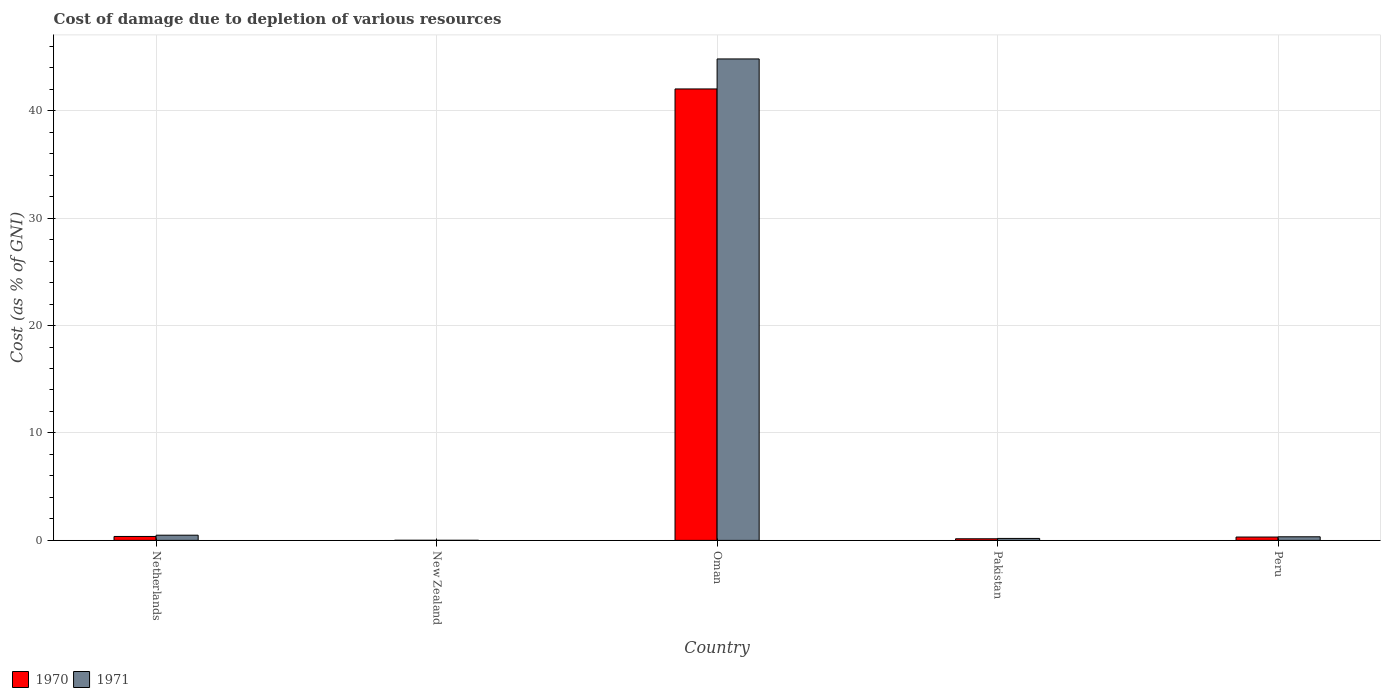How many different coloured bars are there?
Keep it short and to the point. 2. How many groups of bars are there?
Your answer should be very brief. 5. Are the number of bars per tick equal to the number of legend labels?
Make the answer very short. Yes. Are the number of bars on each tick of the X-axis equal?
Provide a succinct answer. Yes. In how many cases, is the number of bars for a given country not equal to the number of legend labels?
Keep it short and to the point. 0. What is the cost of damage caused due to the depletion of various resources in 1971 in Netherlands?
Ensure brevity in your answer.  0.48. Across all countries, what is the maximum cost of damage caused due to the depletion of various resources in 1971?
Offer a very short reply. 44.82. Across all countries, what is the minimum cost of damage caused due to the depletion of various resources in 1970?
Your response must be concise. 0.01. In which country was the cost of damage caused due to the depletion of various resources in 1970 maximum?
Offer a terse response. Oman. In which country was the cost of damage caused due to the depletion of various resources in 1971 minimum?
Give a very brief answer. New Zealand. What is the total cost of damage caused due to the depletion of various resources in 1970 in the graph?
Your answer should be compact. 42.86. What is the difference between the cost of damage caused due to the depletion of various resources in 1971 in Netherlands and that in Pakistan?
Provide a succinct answer. 0.3. What is the difference between the cost of damage caused due to the depletion of various resources in 1970 in Pakistan and the cost of damage caused due to the depletion of various resources in 1971 in New Zealand?
Ensure brevity in your answer.  0.14. What is the average cost of damage caused due to the depletion of various resources in 1970 per country?
Give a very brief answer. 8.57. What is the difference between the cost of damage caused due to the depletion of various resources of/in 1971 and cost of damage caused due to the depletion of various resources of/in 1970 in New Zealand?
Offer a terse response. -0. In how many countries, is the cost of damage caused due to the depletion of various resources in 1970 greater than 42 %?
Offer a terse response. 1. What is the ratio of the cost of damage caused due to the depletion of various resources in 1970 in New Zealand to that in Pakistan?
Give a very brief answer. 0.07. Is the cost of damage caused due to the depletion of various resources in 1971 in Netherlands less than that in New Zealand?
Offer a very short reply. No. What is the difference between the highest and the second highest cost of damage caused due to the depletion of various resources in 1970?
Ensure brevity in your answer.  0.06. What is the difference between the highest and the lowest cost of damage caused due to the depletion of various resources in 1970?
Your answer should be very brief. 42.01. What does the 1st bar from the left in Netherlands represents?
Your answer should be very brief. 1970. What does the 1st bar from the right in Netherlands represents?
Offer a very short reply. 1971. How many bars are there?
Keep it short and to the point. 10. Are all the bars in the graph horizontal?
Make the answer very short. No. What is the difference between two consecutive major ticks on the Y-axis?
Ensure brevity in your answer.  10. Are the values on the major ticks of Y-axis written in scientific E-notation?
Your response must be concise. No. Where does the legend appear in the graph?
Ensure brevity in your answer.  Bottom left. What is the title of the graph?
Offer a very short reply. Cost of damage due to depletion of various resources. What is the label or title of the X-axis?
Provide a short and direct response. Country. What is the label or title of the Y-axis?
Provide a succinct answer. Cost (as % of GNI). What is the Cost (as % of GNI) in 1970 in Netherlands?
Provide a short and direct response. 0.37. What is the Cost (as % of GNI) of 1971 in Netherlands?
Provide a short and direct response. 0.48. What is the Cost (as % of GNI) of 1970 in New Zealand?
Offer a very short reply. 0.01. What is the Cost (as % of GNI) of 1971 in New Zealand?
Your answer should be compact. 0.01. What is the Cost (as % of GNI) of 1970 in Oman?
Provide a short and direct response. 42.02. What is the Cost (as % of GNI) in 1971 in Oman?
Provide a short and direct response. 44.82. What is the Cost (as % of GNI) of 1970 in Pakistan?
Make the answer very short. 0.15. What is the Cost (as % of GNI) of 1971 in Pakistan?
Keep it short and to the point. 0.18. What is the Cost (as % of GNI) in 1970 in Peru?
Provide a succinct answer. 0.31. What is the Cost (as % of GNI) in 1971 in Peru?
Keep it short and to the point. 0.33. Across all countries, what is the maximum Cost (as % of GNI) of 1970?
Provide a succinct answer. 42.02. Across all countries, what is the maximum Cost (as % of GNI) in 1971?
Offer a terse response. 44.82. Across all countries, what is the minimum Cost (as % of GNI) of 1970?
Provide a succinct answer. 0.01. Across all countries, what is the minimum Cost (as % of GNI) in 1971?
Keep it short and to the point. 0.01. What is the total Cost (as % of GNI) of 1970 in the graph?
Give a very brief answer. 42.86. What is the total Cost (as % of GNI) of 1971 in the graph?
Provide a succinct answer. 45.82. What is the difference between the Cost (as % of GNI) in 1970 in Netherlands and that in New Zealand?
Make the answer very short. 0.36. What is the difference between the Cost (as % of GNI) in 1971 in Netherlands and that in New Zealand?
Offer a very short reply. 0.48. What is the difference between the Cost (as % of GNI) in 1970 in Netherlands and that in Oman?
Offer a terse response. -41.66. What is the difference between the Cost (as % of GNI) of 1971 in Netherlands and that in Oman?
Keep it short and to the point. -44.33. What is the difference between the Cost (as % of GNI) in 1970 in Netherlands and that in Pakistan?
Keep it short and to the point. 0.22. What is the difference between the Cost (as % of GNI) of 1971 in Netherlands and that in Pakistan?
Ensure brevity in your answer.  0.3. What is the difference between the Cost (as % of GNI) of 1970 in Netherlands and that in Peru?
Keep it short and to the point. 0.06. What is the difference between the Cost (as % of GNI) of 1971 in Netherlands and that in Peru?
Your response must be concise. 0.15. What is the difference between the Cost (as % of GNI) in 1970 in New Zealand and that in Oman?
Provide a succinct answer. -42.01. What is the difference between the Cost (as % of GNI) of 1971 in New Zealand and that in Oman?
Keep it short and to the point. -44.81. What is the difference between the Cost (as % of GNI) of 1970 in New Zealand and that in Pakistan?
Provide a succinct answer. -0.14. What is the difference between the Cost (as % of GNI) in 1971 in New Zealand and that in Pakistan?
Provide a succinct answer. -0.17. What is the difference between the Cost (as % of GNI) of 1970 in New Zealand and that in Peru?
Offer a very short reply. -0.3. What is the difference between the Cost (as % of GNI) in 1971 in New Zealand and that in Peru?
Offer a very short reply. -0.33. What is the difference between the Cost (as % of GNI) of 1970 in Oman and that in Pakistan?
Provide a short and direct response. 41.87. What is the difference between the Cost (as % of GNI) in 1971 in Oman and that in Pakistan?
Your answer should be compact. 44.63. What is the difference between the Cost (as % of GNI) of 1970 in Oman and that in Peru?
Ensure brevity in your answer.  41.71. What is the difference between the Cost (as % of GNI) of 1971 in Oman and that in Peru?
Make the answer very short. 44.48. What is the difference between the Cost (as % of GNI) of 1970 in Pakistan and that in Peru?
Ensure brevity in your answer.  -0.16. What is the difference between the Cost (as % of GNI) in 1971 in Pakistan and that in Peru?
Your answer should be compact. -0.15. What is the difference between the Cost (as % of GNI) of 1970 in Netherlands and the Cost (as % of GNI) of 1971 in New Zealand?
Ensure brevity in your answer.  0.36. What is the difference between the Cost (as % of GNI) of 1970 in Netherlands and the Cost (as % of GNI) of 1971 in Oman?
Offer a terse response. -44.45. What is the difference between the Cost (as % of GNI) in 1970 in Netherlands and the Cost (as % of GNI) in 1971 in Pakistan?
Give a very brief answer. 0.18. What is the difference between the Cost (as % of GNI) in 1970 in Netherlands and the Cost (as % of GNI) in 1971 in Peru?
Your answer should be very brief. 0.03. What is the difference between the Cost (as % of GNI) of 1970 in New Zealand and the Cost (as % of GNI) of 1971 in Oman?
Give a very brief answer. -44.8. What is the difference between the Cost (as % of GNI) of 1970 in New Zealand and the Cost (as % of GNI) of 1971 in Pakistan?
Provide a short and direct response. -0.17. What is the difference between the Cost (as % of GNI) in 1970 in New Zealand and the Cost (as % of GNI) in 1971 in Peru?
Your answer should be very brief. -0.32. What is the difference between the Cost (as % of GNI) of 1970 in Oman and the Cost (as % of GNI) of 1971 in Pakistan?
Your answer should be very brief. 41.84. What is the difference between the Cost (as % of GNI) in 1970 in Oman and the Cost (as % of GNI) in 1971 in Peru?
Offer a very short reply. 41.69. What is the difference between the Cost (as % of GNI) in 1970 in Pakistan and the Cost (as % of GNI) in 1971 in Peru?
Keep it short and to the point. -0.18. What is the average Cost (as % of GNI) in 1970 per country?
Give a very brief answer. 8.57. What is the average Cost (as % of GNI) of 1971 per country?
Offer a terse response. 9.16. What is the difference between the Cost (as % of GNI) of 1970 and Cost (as % of GNI) of 1971 in Netherlands?
Make the answer very short. -0.12. What is the difference between the Cost (as % of GNI) in 1970 and Cost (as % of GNI) in 1971 in New Zealand?
Make the answer very short. 0. What is the difference between the Cost (as % of GNI) in 1970 and Cost (as % of GNI) in 1971 in Oman?
Make the answer very short. -2.79. What is the difference between the Cost (as % of GNI) of 1970 and Cost (as % of GNI) of 1971 in Pakistan?
Keep it short and to the point. -0.03. What is the difference between the Cost (as % of GNI) of 1970 and Cost (as % of GNI) of 1971 in Peru?
Your answer should be compact. -0.02. What is the ratio of the Cost (as % of GNI) of 1970 in Netherlands to that in New Zealand?
Offer a terse response. 34.53. What is the ratio of the Cost (as % of GNI) in 1971 in Netherlands to that in New Zealand?
Keep it short and to the point. 57.9. What is the ratio of the Cost (as % of GNI) of 1970 in Netherlands to that in Oman?
Provide a short and direct response. 0.01. What is the ratio of the Cost (as % of GNI) in 1971 in Netherlands to that in Oman?
Offer a terse response. 0.01. What is the ratio of the Cost (as % of GNI) of 1970 in Netherlands to that in Pakistan?
Give a very brief answer. 2.44. What is the ratio of the Cost (as % of GNI) in 1971 in Netherlands to that in Pakistan?
Your answer should be compact. 2.64. What is the ratio of the Cost (as % of GNI) in 1970 in Netherlands to that in Peru?
Your response must be concise. 1.18. What is the ratio of the Cost (as % of GNI) of 1971 in Netherlands to that in Peru?
Your response must be concise. 1.45. What is the ratio of the Cost (as % of GNI) of 1970 in New Zealand to that in Pakistan?
Your response must be concise. 0.07. What is the ratio of the Cost (as % of GNI) of 1971 in New Zealand to that in Pakistan?
Offer a terse response. 0.05. What is the ratio of the Cost (as % of GNI) of 1970 in New Zealand to that in Peru?
Your answer should be compact. 0.03. What is the ratio of the Cost (as % of GNI) of 1971 in New Zealand to that in Peru?
Offer a terse response. 0.03. What is the ratio of the Cost (as % of GNI) of 1970 in Oman to that in Pakistan?
Offer a terse response. 279.8. What is the ratio of the Cost (as % of GNI) in 1971 in Oman to that in Pakistan?
Ensure brevity in your answer.  244.84. What is the ratio of the Cost (as % of GNI) of 1970 in Oman to that in Peru?
Ensure brevity in your answer.  135.02. What is the ratio of the Cost (as % of GNI) in 1971 in Oman to that in Peru?
Make the answer very short. 133.93. What is the ratio of the Cost (as % of GNI) of 1970 in Pakistan to that in Peru?
Your answer should be very brief. 0.48. What is the ratio of the Cost (as % of GNI) of 1971 in Pakistan to that in Peru?
Keep it short and to the point. 0.55. What is the difference between the highest and the second highest Cost (as % of GNI) of 1970?
Provide a short and direct response. 41.66. What is the difference between the highest and the second highest Cost (as % of GNI) of 1971?
Offer a very short reply. 44.33. What is the difference between the highest and the lowest Cost (as % of GNI) in 1970?
Your response must be concise. 42.01. What is the difference between the highest and the lowest Cost (as % of GNI) in 1971?
Make the answer very short. 44.81. 